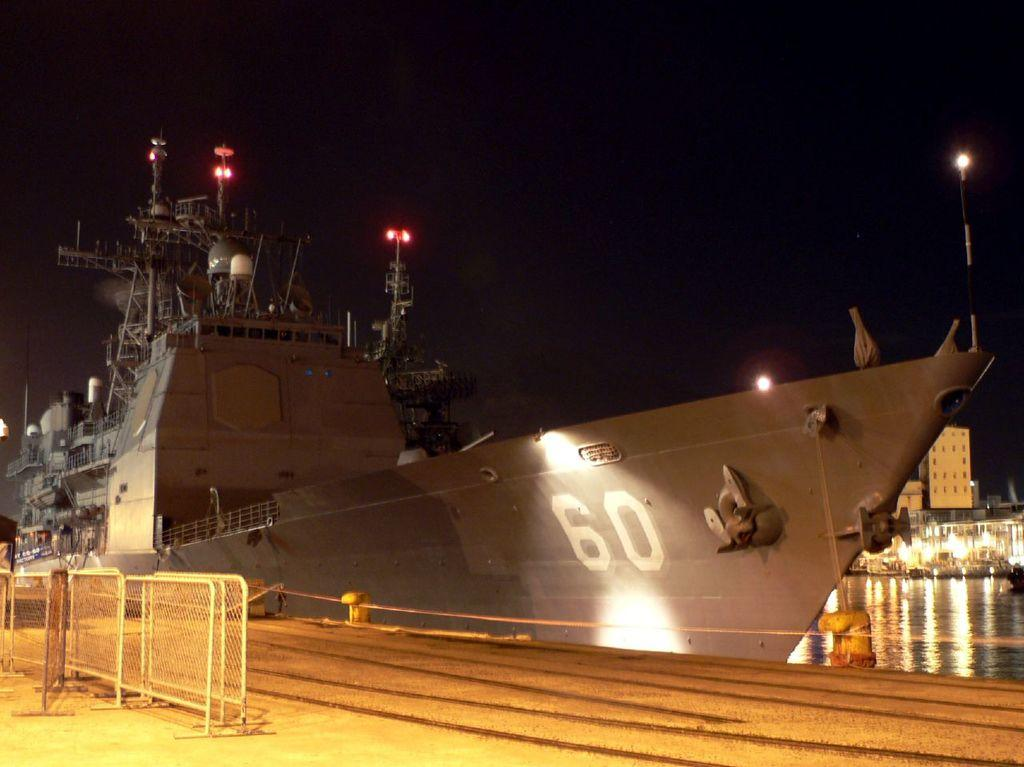What is the main subject of the image? The main subject of the image is a ship. What can be seen in the background of the image? There are buildings in the background of the image. What is the ship located near in the image? Fencing is present on the left side of the image. What type of environment is depicted in the image? The image shows a ship near water, with buildings in the background. What type of stove can be seen in the image? There is no stove present in the image. What pet is visible on the ship in the image? There are no pets visible in the image. 